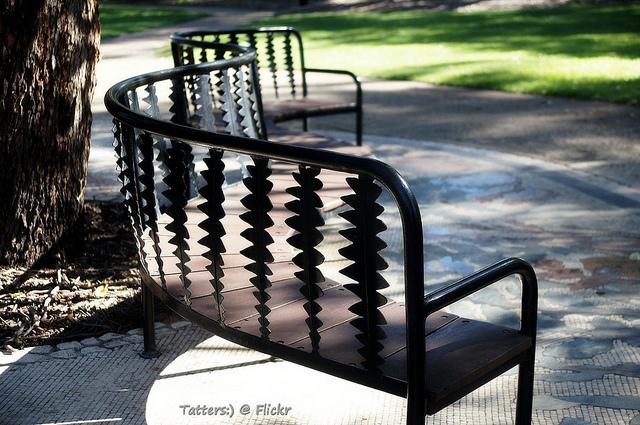What shape is the bench seat?
Keep it brief. Curved. Is there a shadow?
Write a very short answer. Yes. Is this one bench or multiple benches?
Quick response, please. 1. 